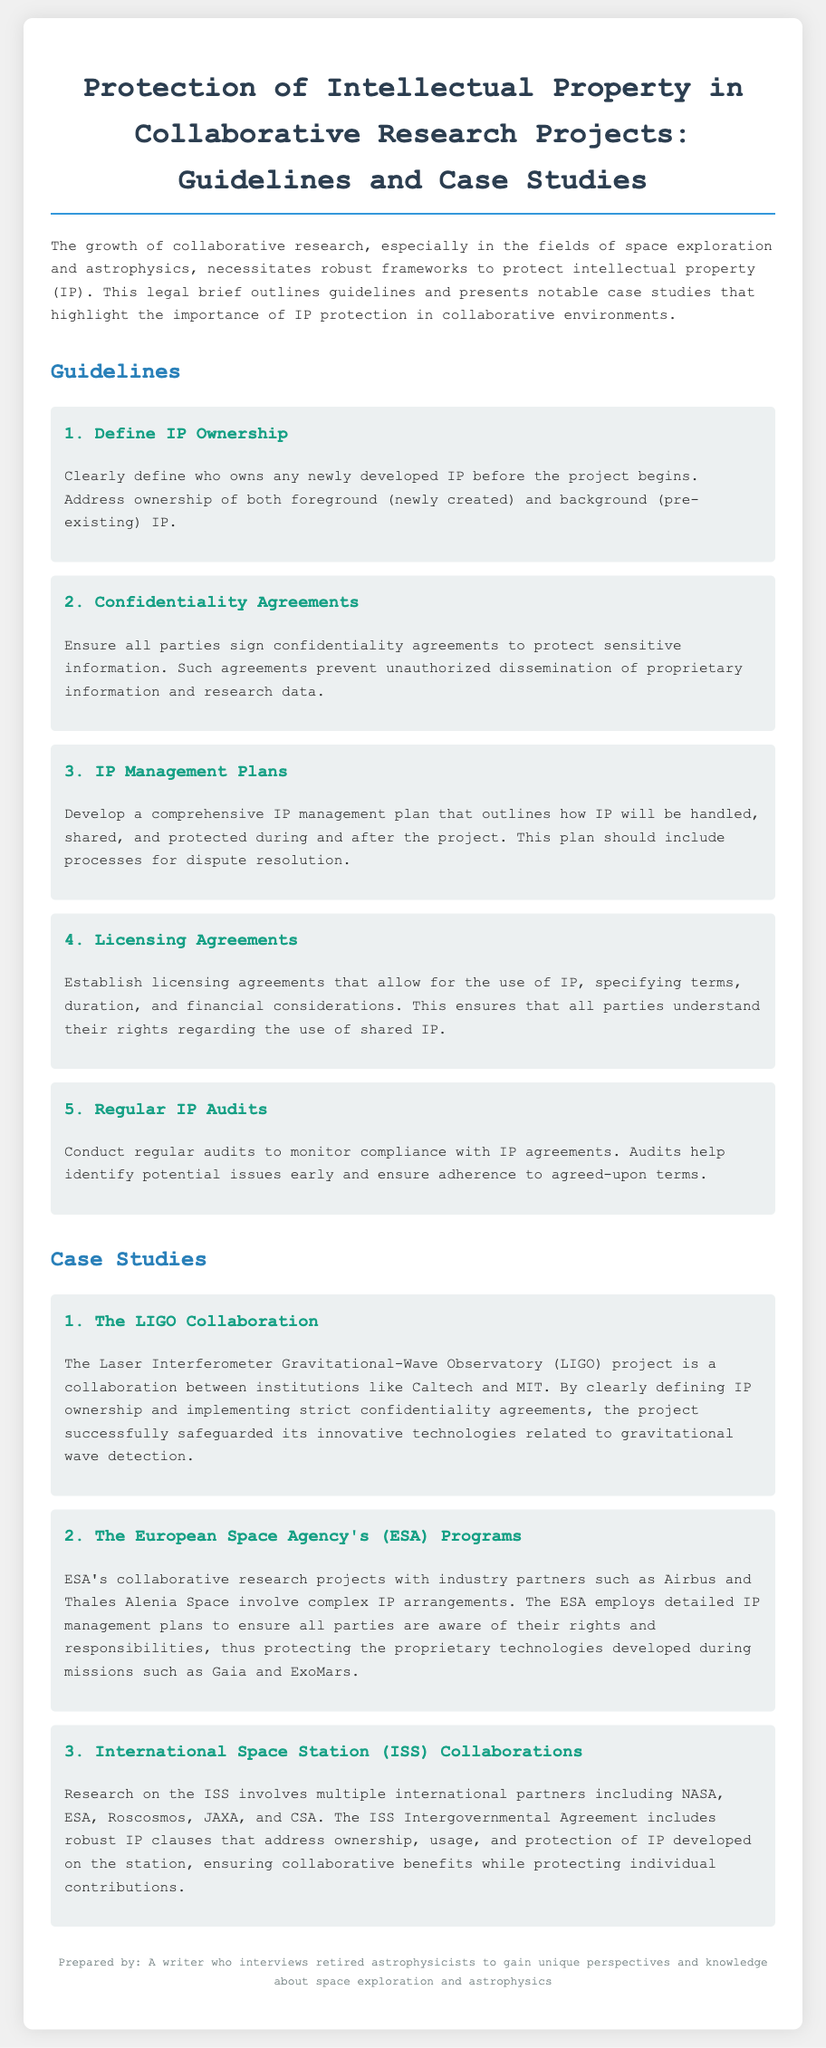What is the title of the document? The title of the document is the first heading labeled at the top, summarizing the contents regarding IP protection.
Answer: Protection of Intellectual Property in Collaborative Research Projects: Guidelines and Case Studies What is the primary focus of the legal brief? The primary focus is mentioned in the introduction paragraph, emphasizing the need for frameworks to protect intellectual property in collaborative research.
Answer: Protecting intellectual property How many guidelines are presented in the document? The document lists individual guidelines, and by counting the headings, we find the total number.
Answer: Five Who are the institutions involved in the LIGO collaboration? The institutions are explicitly named in the case study section addressing the LIGO project.
Answer: Caltech and MIT What type of agreements should all parties sign according to the guidelines? The specific type of agreement mentioned in the guidelines that ensures the protection of sensitive information is clearly stated.
Answer: Confidentiality agreements What project is associated with the European Space Agency mentioned in the document? The specific projects outlined relate to ESA and its collaborative arrangements with industry partners.
Answer: Gaia and ExoMars What is suggested to ensure the use of IP is clear among collaborators? The document recommends establishing a specific type of agreement to clarify terms regarding the use of IP.
Answer: Licensing agreements How often should IP audits be conducted according to the guidelines? The guidelines mention the frequency of these audits, which helps in monitoring compliance.
Answer: Regularly What overarching agreement governs IP issues for the ISS collaborations? This is highlighted in the document as a crucial framework for addressing IP ownership and usage among international partners.
Answer: ISS Intergovernmental Agreement 